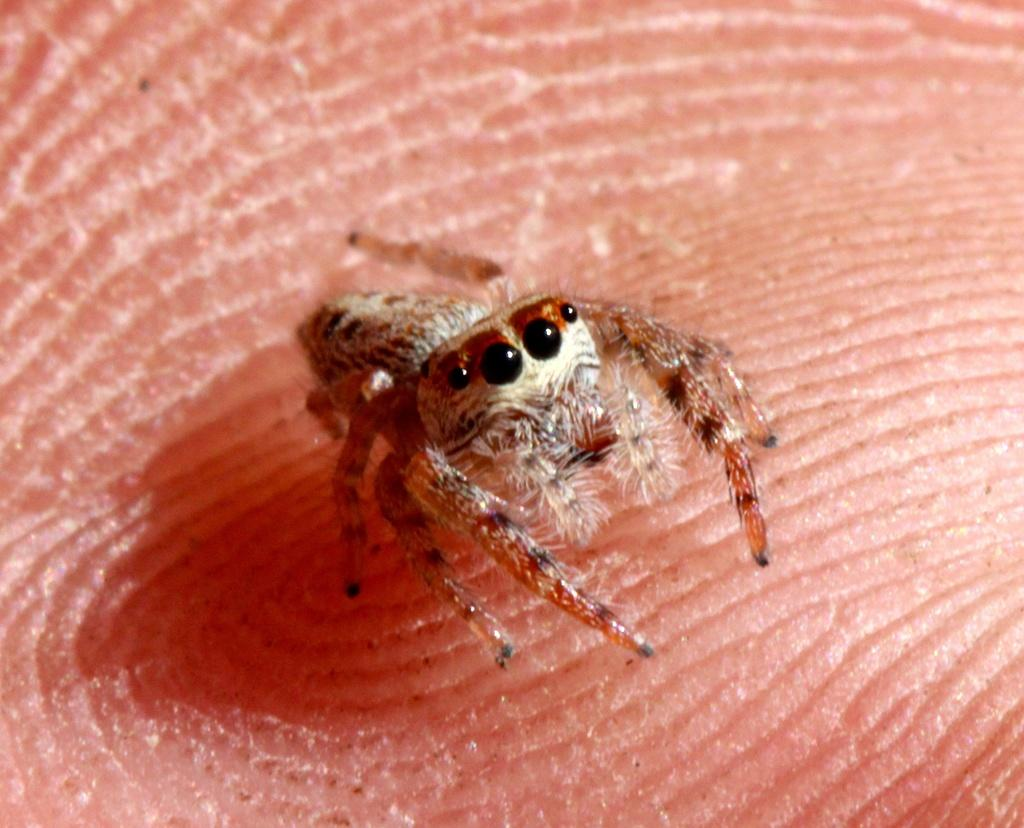What is the main subject of the image? The main subject of the image is a spider. Where is the spider located in the image? The spider is on a hand in the image. What type of approval does the robin give to the spider in the image? There is no robin present in the image, so it is not possible to determine if the robin gives any approval to the spider. 